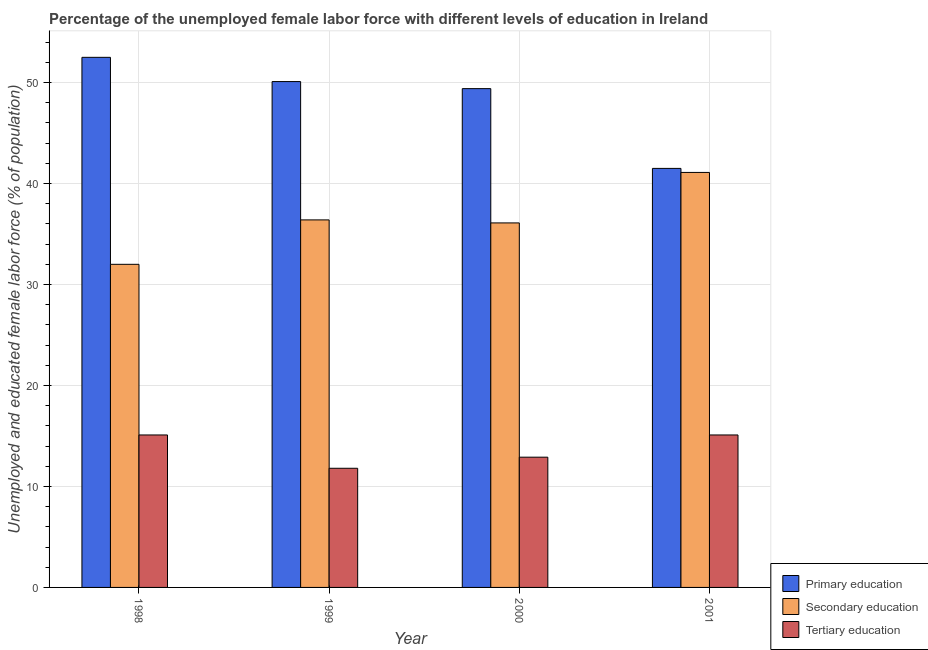How many different coloured bars are there?
Ensure brevity in your answer.  3. How many bars are there on the 1st tick from the right?
Make the answer very short. 3. What is the label of the 2nd group of bars from the left?
Your response must be concise. 1999. What is the percentage of female labor force who received primary education in 1998?
Your response must be concise. 52.5. Across all years, what is the maximum percentage of female labor force who received secondary education?
Ensure brevity in your answer.  41.1. What is the total percentage of female labor force who received primary education in the graph?
Your response must be concise. 193.5. What is the difference between the percentage of female labor force who received secondary education in 1998 and that in 2001?
Offer a very short reply. -9.1. What is the difference between the percentage of female labor force who received tertiary education in 1999 and the percentage of female labor force who received secondary education in 1998?
Your answer should be compact. -3.3. What is the average percentage of female labor force who received tertiary education per year?
Give a very brief answer. 13.73. In the year 2000, what is the difference between the percentage of female labor force who received primary education and percentage of female labor force who received secondary education?
Give a very brief answer. 0. In how many years, is the percentage of female labor force who received secondary education greater than 4 %?
Offer a terse response. 4. What is the ratio of the percentage of female labor force who received secondary education in 1999 to that in 2000?
Offer a very short reply. 1.01. Is the percentage of female labor force who received tertiary education in 1998 less than that in 2001?
Offer a terse response. No. Is the difference between the percentage of female labor force who received tertiary education in 1999 and 2000 greater than the difference between the percentage of female labor force who received primary education in 1999 and 2000?
Give a very brief answer. No. Is the sum of the percentage of female labor force who received secondary education in 1998 and 2001 greater than the maximum percentage of female labor force who received primary education across all years?
Offer a terse response. Yes. What does the 2nd bar from the left in 1998 represents?
Offer a terse response. Secondary education. Are all the bars in the graph horizontal?
Your response must be concise. No. How many years are there in the graph?
Provide a short and direct response. 4. Does the graph contain any zero values?
Your response must be concise. No. Does the graph contain grids?
Your answer should be very brief. Yes. What is the title of the graph?
Keep it short and to the point. Percentage of the unemployed female labor force with different levels of education in Ireland. Does "Ages 15-20" appear as one of the legend labels in the graph?
Ensure brevity in your answer.  No. What is the label or title of the X-axis?
Your answer should be very brief. Year. What is the label or title of the Y-axis?
Offer a terse response. Unemployed and educated female labor force (% of population). What is the Unemployed and educated female labor force (% of population) in Primary education in 1998?
Provide a short and direct response. 52.5. What is the Unemployed and educated female labor force (% of population) in Secondary education in 1998?
Provide a short and direct response. 32. What is the Unemployed and educated female labor force (% of population) in Tertiary education in 1998?
Keep it short and to the point. 15.1. What is the Unemployed and educated female labor force (% of population) in Primary education in 1999?
Offer a terse response. 50.1. What is the Unemployed and educated female labor force (% of population) of Secondary education in 1999?
Offer a terse response. 36.4. What is the Unemployed and educated female labor force (% of population) of Tertiary education in 1999?
Keep it short and to the point. 11.8. What is the Unemployed and educated female labor force (% of population) in Primary education in 2000?
Provide a succinct answer. 49.4. What is the Unemployed and educated female labor force (% of population) in Secondary education in 2000?
Ensure brevity in your answer.  36.1. What is the Unemployed and educated female labor force (% of population) in Tertiary education in 2000?
Your answer should be compact. 12.9. What is the Unemployed and educated female labor force (% of population) of Primary education in 2001?
Offer a terse response. 41.5. What is the Unemployed and educated female labor force (% of population) in Secondary education in 2001?
Offer a terse response. 41.1. What is the Unemployed and educated female labor force (% of population) in Tertiary education in 2001?
Your answer should be very brief. 15.1. Across all years, what is the maximum Unemployed and educated female labor force (% of population) of Primary education?
Your response must be concise. 52.5. Across all years, what is the maximum Unemployed and educated female labor force (% of population) of Secondary education?
Your answer should be compact. 41.1. Across all years, what is the maximum Unemployed and educated female labor force (% of population) of Tertiary education?
Your answer should be compact. 15.1. Across all years, what is the minimum Unemployed and educated female labor force (% of population) in Primary education?
Give a very brief answer. 41.5. Across all years, what is the minimum Unemployed and educated female labor force (% of population) of Tertiary education?
Give a very brief answer. 11.8. What is the total Unemployed and educated female labor force (% of population) in Primary education in the graph?
Make the answer very short. 193.5. What is the total Unemployed and educated female labor force (% of population) in Secondary education in the graph?
Provide a succinct answer. 145.6. What is the total Unemployed and educated female labor force (% of population) in Tertiary education in the graph?
Keep it short and to the point. 54.9. What is the difference between the Unemployed and educated female labor force (% of population) in Secondary education in 1998 and that in 1999?
Your answer should be very brief. -4.4. What is the difference between the Unemployed and educated female labor force (% of population) of Primary education in 1998 and that in 2000?
Provide a succinct answer. 3.1. What is the difference between the Unemployed and educated female labor force (% of population) of Tertiary education in 1998 and that in 2000?
Offer a very short reply. 2.2. What is the difference between the Unemployed and educated female labor force (% of population) in Primary education in 1999 and that in 2000?
Provide a succinct answer. 0.7. What is the difference between the Unemployed and educated female labor force (% of population) in Secondary education in 1999 and that in 2000?
Your response must be concise. 0.3. What is the difference between the Unemployed and educated female labor force (% of population) of Primary education in 1999 and that in 2001?
Your answer should be compact. 8.6. What is the difference between the Unemployed and educated female labor force (% of population) in Secondary education in 1999 and that in 2001?
Your answer should be compact. -4.7. What is the difference between the Unemployed and educated female labor force (% of population) in Tertiary education in 1999 and that in 2001?
Provide a short and direct response. -3.3. What is the difference between the Unemployed and educated female labor force (% of population) of Primary education in 2000 and that in 2001?
Provide a short and direct response. 7.9. What is the difference between the Unemployed and educated female labor force (% of population) of Primary education in 1998 and the Unemployed and educated female labor force (% of population) of Secondary education in 1999?
Make the answer very short. 16.1. What is the difference between the Unemployed and educated female labor force (% of population) of Primary education in 1998 and the Unemployed and educated female labor force (% of population) of Tertiary education in 1999?
Offer a very short reply. 40.7. What is the difference between the Unemployed and educated female labor force (% of population) in Secondary education in 1998 and the Unemployed and educated female labor force (% of population) in Tertiary education in 1999?
Ensure brevity in your answer.  20.2. What is the difference between the Unemployed and educated female labor force (% of population) in Primary education in 1998 and the Unemployed and educated female labor force (% of population) in Secondary education in 2000?
Your response must be concise. 16.4. What is the difference between the Unemployed and educated female labor force (% of population) in Primary education in 1998 and the Unemployed and educated female labor force (% of population) in Tertiary education in 2000?
Your answer should be compact. 39.6. What is the difference between the Unemployed and educated female labor force (% of population) of Primary education in 1998 and the Unemployed and educated female labor force (% of population) of Secondary education in 2001?
Offer a terse response. 11.4. What is the difference between the Unemployed and educated female labor force (% of population) of Primary education in 1998 and the Unemployed and educated female labor force (% of population) of Tertiary education in 2001?
Keep it short and to the point. 37.4. What is the difference between the Unemployed and educated female labor force (% of population) in Secondary education in 1998 and the Unemployed and educated female labor force (% of population) in Tertiary education in 2001?
Your answer should be very brief. 16.9. What is the difference between the Unemployed and educated female labor force (% of population) in Primary education in 1999 and the Unemployed and educated female labor force (% of population) in Secondary education in 2000?
Offer a very short reply. 14. What is the difference between the Unemployed and educated female labor force (% of population) in Primary education in 1999 and the Unemployed and educated female labor force (% of population) in Tertiary education in 2000?
Keep it short and to the point. 37.2. What is the difference between the Unemployed and educated female labor force (% of population) in Primary education in 1999 and the Unemployed and educated female labor force (% of population) in Secondary education in 2001?
Give a very brief answer. 9. What is the difference between the Unemployed and educated female labor force (% of population) of Primary education in 1999 and the Unemployed and educated female labor force (% of population) of Tertiary education in 2001?
Give a very brief answer. 35. What is the difference between the Unemployed and educated female labor force (% of population) in Secondary education in 1999 and the Unemployed and educated female labor force (% of population) in Tertiary education in 2001?
Keep it short and to the point. 21.3. What is the difference between the Unemployed and educated female labor force (% of population) of Primary education in 2000 and the Unemployed and educated female labor force (% of population) of Tertiary education in 2001?
Offer a terse response. 34.3. What is the average Unemployed and educated female labor force (% of population) in Primary education per year?
Offer a very short reply. 48.38. What is the average Unemployed and educated female labor force (% of population) in Secondary education per year?
Your response must be concise. 36.4. What is the average Unemployed and educated female labor force (% of population) of Tertiary education per year?
Provide a succinct answer. 13.72. In the year 1998, what is the difference between the Unemployed and educated female labor force (% of population) of Primary education and Unemployed and educated female labor force (% of population) of Tertiary education?
Provide a short and direct response. 37.4. In the year 1999, what is the difference between the Unemployed and educated female labor force (% of population) in Primary education and Unemployed and educated female labor force (% of population) in Tertiary education?
Provide a succinct answer. 38.3. In the year 1999, what is the difference between the Unemployed and educated female labor force (% of population) of Secondary education and Unemployed and educated female labor force (% of population) of Tertiary education?
Provide a short and direct response. 24.6. In the year 2000, what is the difference between the Unemployed and educated female labor force (% of population) in Primary education and Unemployed and educated female labor force (% of population) in Tertiary education?
Offer a very short reply. 36.5. In the year 2000, what is the difference between the Unemployed and educated female labor force (% of population) of Secondary education and Unemployed and educated female labor force (% of population) of Tertiary education?
Provide a short and direct response. 23.2. In the year 2001, what is the difference between the Unemployed and educated female labor force (% of population) of Primary education and Unemployed and educated female labor force (% of population) of Tertiary education?
Make the answer very short. 26.4. In the year 2001, what is the difference between the Unemployed and educated female labor force (% of population) of Secondary education and Unemployed and educated female labor force (% of population) of Tertiary education?
Provide a short and direct response. 26. What is the ratio of the Unemployed and educated female labor force (% of population) in Primary education in 1998 to that in 1999?
Offer a very short reply. 1.05. What is the ratio of the Unemployed and educated female labor force (% of population) of Secondary education in 1998 to that in 1999?
Ensure brevity in your answer.  0.88. What is the ratio of the Unemployed and educated female labor force (% of population) of Tertiary education in 1998 to that in 1999?
Offer a very short reply. 1.28. What is the ratio of the Unemployed and educated female labor force (% of population) in Primary education in 1998 to that in 2000?
Give a very brief answer. 1.06. What is the ratio of the Unemployed and educated female labor force (% of population) in Secondary education in 1998 to that in 2000?
Offer a very short reply. 0.89. What is the ratio of the Unemployed and educated female labor force (% of population) of Tertiary education in 1998 to that in 2000?
Offer a very short reply. 1.17. What is the ratio of the Unemployed and educated female labor force (% of population) in Primary education in 1998 to that in 2001?
Your response must be concise. 1.27. What is the ratio of the Unemployed and educated female labor force (% of population) in Secondary education in 1998 to that in 2001?
Your answer should be very brief. 0.78. What is the ratio of the Unemployed and educated female labor force (% of population) in Primary education in 1999 to that in 2000?
Your answer should be very brief. 1.01. What is the ratio of the Unemployed and educated female labor force (% of population) of Secondary education in 1999 to that in 2000?
Offer a very short reply. 1.01. What is the ratio of the Unemployed and educated female labor force (% of population) of Tertiary education in 1999 to that in 2000?
Your answer should be very brief. 0.91. What is the ratio of the Unemployed and educated female labor force (% of population) in Primary education in 1999 to that in 2001?
Your answer should be very brief. 1.21. What is the ratio of the Unemployed and educated female labor force (% of population) in Secondary education in 1999 to that in 2001?
Provide a succinct answer. 0.89. What is the ratio of the Unemployed and educated female labor force (% of population) in Tertiary education in 1999 to that in 2001?
Make the answer very short. 0.78. What is the ratio of the Unemployed and educated female labor force (% of population) in Primary education in 2000 to that in 2001?
Keep it short and to the point. 1.19. What is the ratio of the Unemployed and educated female labor force (% of population) in Secondary education in 2000 to that in 2001?
Provide a short and direct response. 0.88. What is the ratio of the Unemployed and educated female labor force (% of population) of Tertiary education in 2000 to that in 2001?
Keep it short and to the point. 0.85. What is the difference between the highest and the second highest Unemployed and educated female labor force (% of population) of Primary education?
Provide a short and direct response. 2.4. What is the difference between the highest and the second highest Unemployed and educated female labor force (% of population) in Tertiary education?
Provide a succinct answer. 0. What is the difference between the highest and the lowest Unemployed and educated female labor force (% of population) of Tertiary education?
Provide a short and direct response. 3.3. 